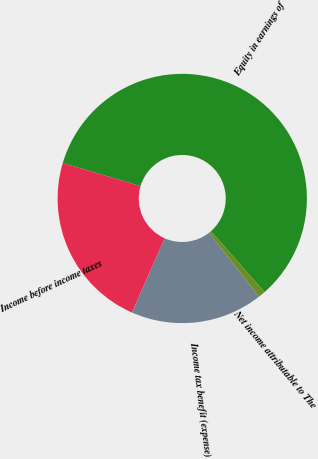Convert chart to OTSL. <chart><loc_0><loc_0><loc_500><loc_500><pie_chart><fcel>Equity in earnings of<fcel>Income before income taxes<fcel>Income tax benefit (expense)<fcel>Net income attributable to The<nl><fcel>58.94%<fcel>22.98%<fcel>17.18%<fcel>0.9%<nl></chart> 